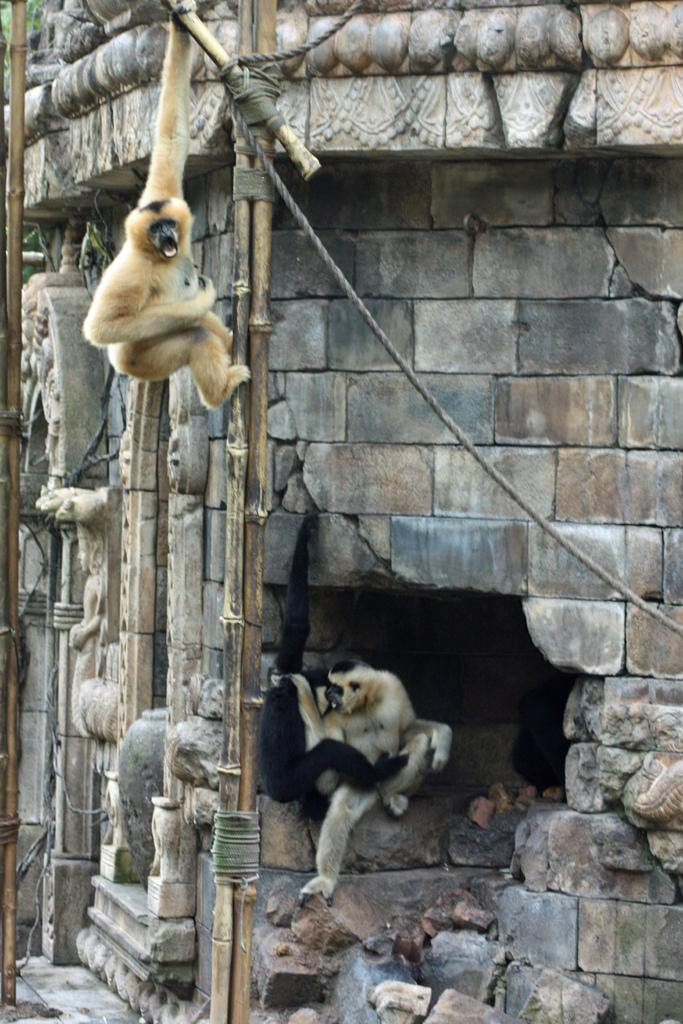What is the main subject of the image? The main subject of the image is a monkey. What is the monkey doing in the image? There is a monkey climbing on a wooden stick, and there are monkeys sitting on the rocks of a building in the image. What type of beef can be seen hanging from the wooden stick in the image? There is no beef present in the image; it features monkeys climbing on a wooden stick and sitting on the rocks of a building. 